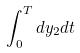<formula> <loc_0><loc_0><loc_500><loc_500>\int _ { 0 } ^ { T } d y _ { 2 } d t</formula> 